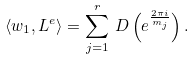Convert formula to latex. <formula><loc_0><loc_0><loc_500><loc_500>\langle w _ { 1 } , L ^ { e } \rangle = \sum _ { j = 1 } ^ { r } \, D \left ( e ^ { \frac { 2 \pi i } { m _ { j } } } \right ) .</formula> 